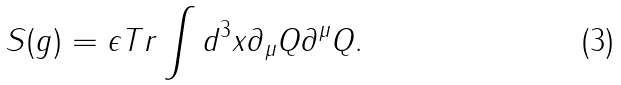<formula> <loc_0><loc_0><loc_500><loc_500>S ( g ) = \epsilon T r \int d ^ { 3 } x \partial _ { \mu } Q \partial ^ { \mu } Q .</formula> 